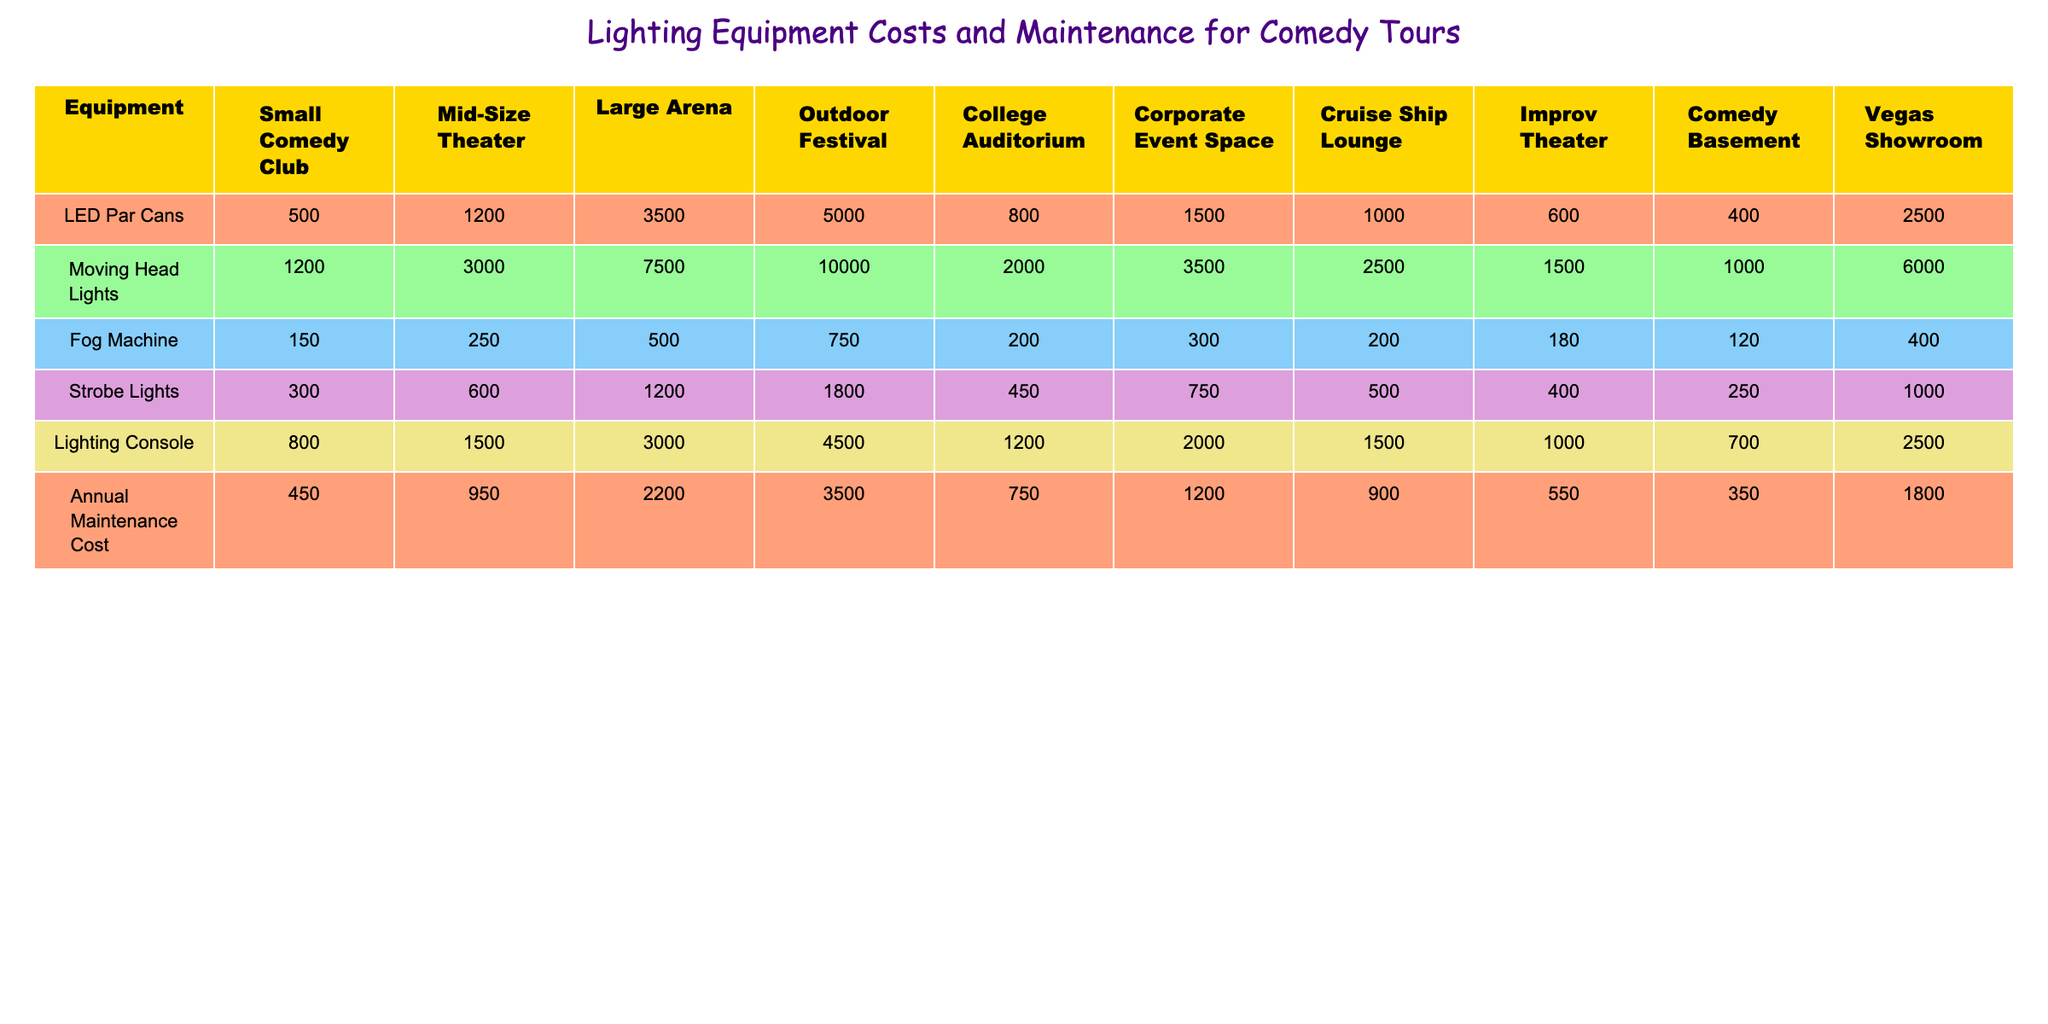What is the total cost of LED Par Cans for a Large Arena? The table shows that the cost of LED Par Cans for a Large Arena is listed as 3500.
Answer: 3500 Which venue has the highest Annual Maintenance Cost? By comparing the Annual Maintenance Cost column in the table, Outdoor Festival has the highest value at 3500.
Answer: 3500 How much do Moving Head Lights cost in a Mid-Size Theater? The table indicates that the cost of Moving Head Lights at a Mid-Size Theater is 3000.
Answer: 3000 True or False: College Auditoriums have a higher cost for Strobe Lights than Small Comedy Clubs. The table shows Strobe Lights cost 450 in College Auditoriums and 300 in Small Comedy Clubs, so the statement is true.
Answer: True What is the average cost of Fog Machines across all venues? The costs for Fog Machines are: 150, 250, 500, 750, 200, 300, 200, 180, 120, 400. The sum is 2800 and dividing by the number of venues (10), gives an average of 280.
Answer: 280 Which venue type has the lowest total equipment cost? To find the lowest total equipment cost, we sum the costs of all equipment for each venue. For Comedy Basement, the total is 400 + 1000 + 120 + 250 + 700 = 2470, which is the lowest.
Answer: 2470 What is the difference in cost between Moving Head Lights at a Large Arena and a Corporate Event Space? The cost of Moving Head Lights is 7500 at a Large Arena and 3500 at a Corporate Event Space. The difference is 7500 - 3500 = 4000.
Answer: 4000 How much does it cost to rent all lighting equipment for an Outdoor Festival compared to a Small Comedy Club? For Outdoor Festival, the total is 5000 + 10000 + 750 + 1800 + 4500 = 20700, and for Small Comedy Club, it totals to 500 + 1200 + 150 + 300 + 800 = 1950. The cost difference is 20700 - 1950 = 18750.
Answer: 18750 What is the total cost of Strobe Lights across all venues? By adding the Strobe Lights costs from each venue, we find: 300 + 600 + 1200 + 1800 + 450 + 750 + 500 + 400 + 1000 = 5100.
Answer: 5100 Which venue has the best lighting setup based on the total initial equipment costs? After calculating the total costs for each venue, the Outdoor Festival with a total of 20700 has the best lighting setup based on costs.
Answer: Outdoor Festival 